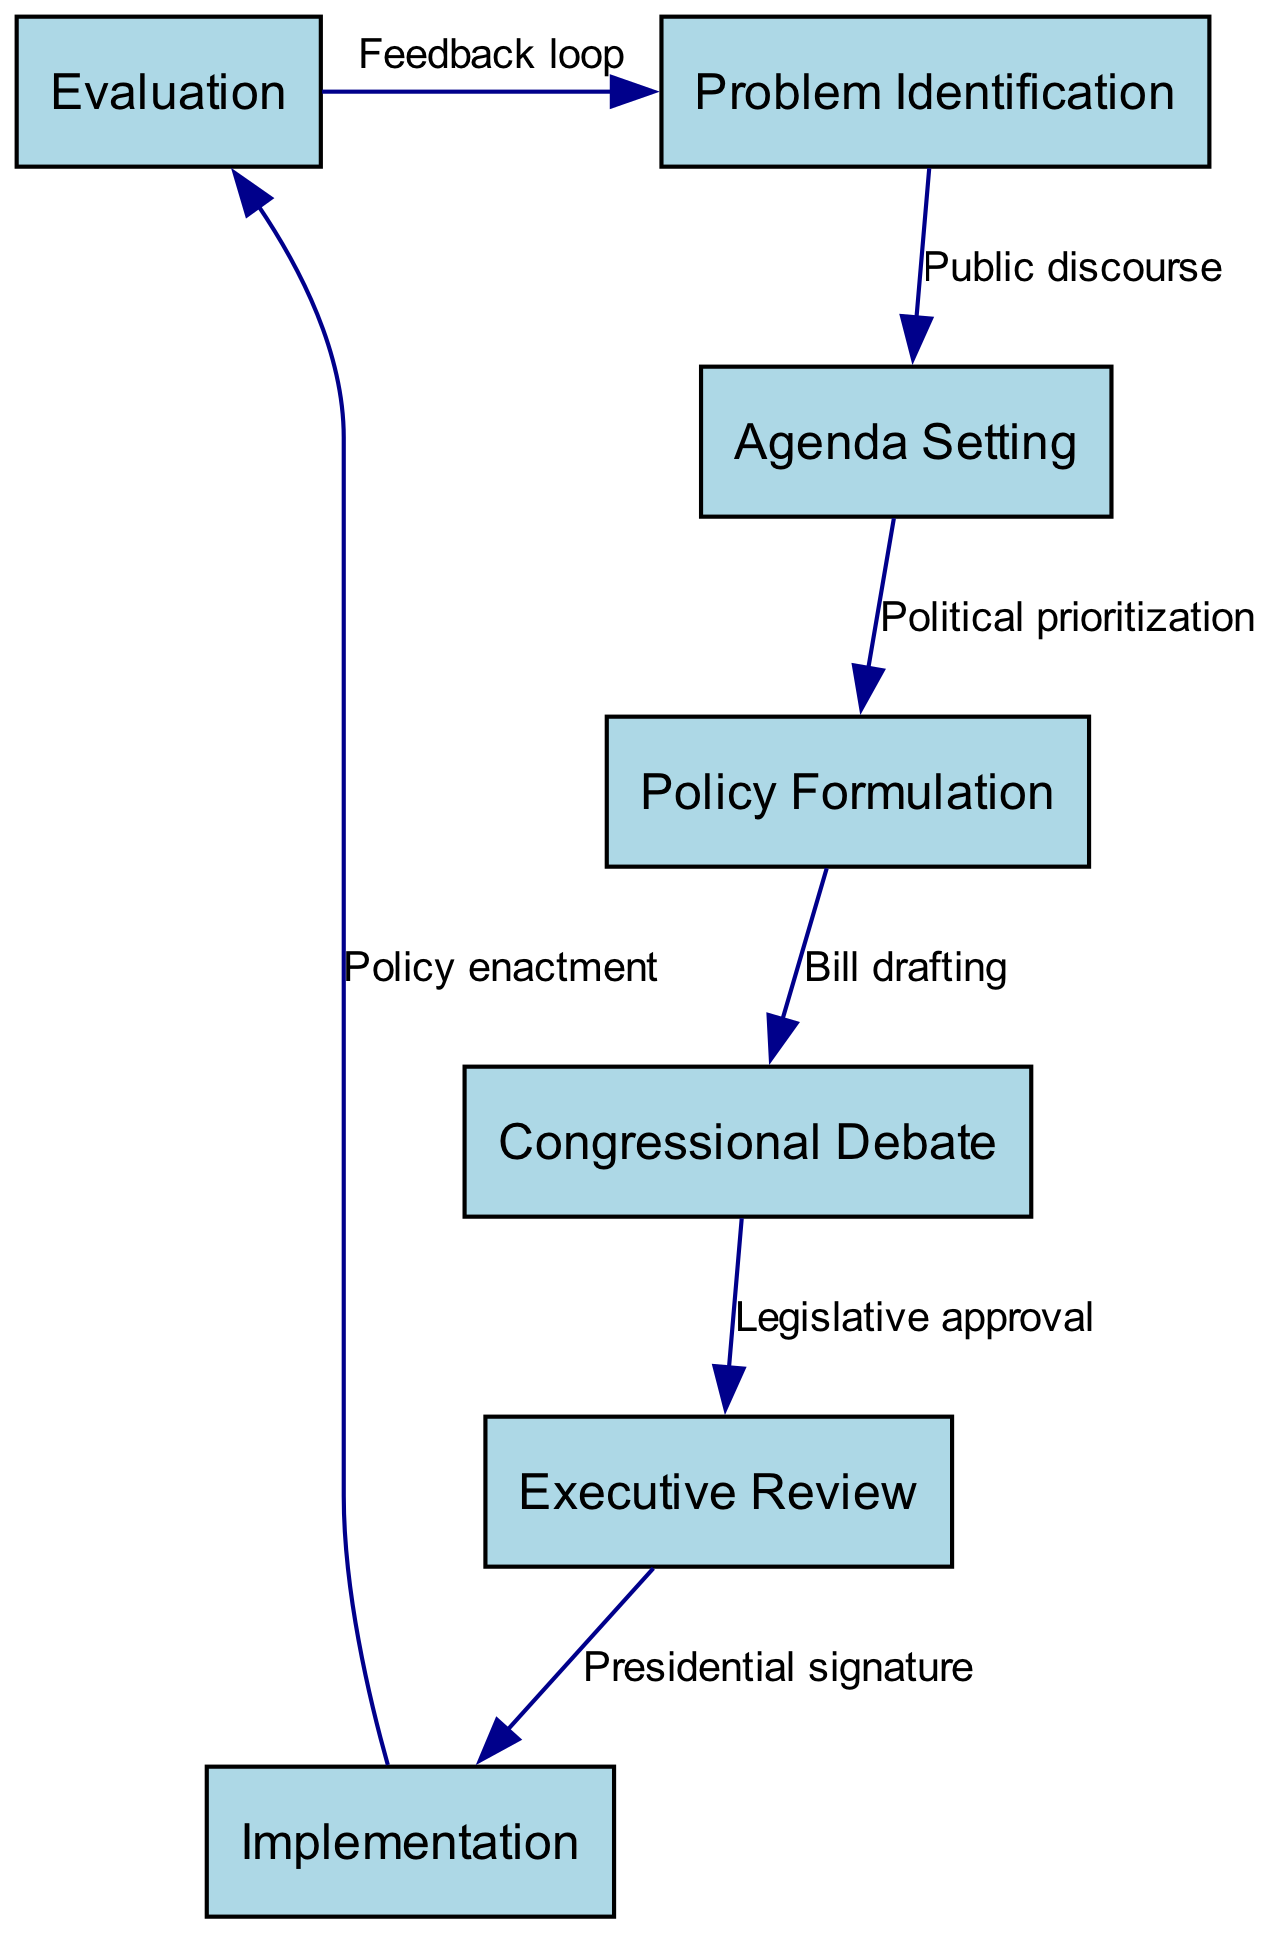What is the first step in the policy formulation process? The diagram indicates that the first step is "Problem Identification." This is clear from the first node in the flowchart, which starts the policy formulation process.
Answer: Problem Identification How many nodes are present in the diagram? By counting the nodes listed in the provided data, there are a total of seven nodes representing different steps in the policy formulation and implementation process.
Answer: Seven What is the relationship between "Agenda Setting" and "Policy Formulation"? The edge connecting "Agenda Setting" and "Policy Formulation" is labeled as "Political prioritization." This indicates that agenda setting leads into the process of formulating policy.
Answer: Political prioritization Which step follows "Congressional Debate"? The diagram shows that following "Congressional Debate," the next step is "Executive Review," indicated by a directed edge pointing to it from the debate node.
Answer: Executive Review What signifies the end of the policy implementation cycle in the diagram? The final step in the cycle is "Evaluation." It loops back to "Problem Identification," indicating that evaluations can lead to new problem identifications, thus completing the cycle.
Answer: Evaluation What is the nature of the feedback loop in this diagram? The diagram has a feedback loop connecting "Evaluation" back to "Problem Identification." This signifies an iterative process where evaluations can generate new issues or problems to be identified.
Answer: Iterative process What is the total number of edges in the diagram? The number of edges is counted by looking at the connections between nodes. From the provided data, there are six edges indicating direct relationships between the steps of the process.
Answer: Six What is required to move from "Implementation" to "Evaluation"? The transition from "Implementation" to "Evaluation" is described by the edge labeled "Policy enactment," which shows that the enactment of policy leads to its evaluation.
Answer: Policy enactment What role does the "Executive Review" play in the policy formulation process? The "Executive Review" is a critical step where the president or executive branch reviews the drafted policy before it can be implemented, as shown by its placement in the flowchart.
Answer: Review by executive branch 